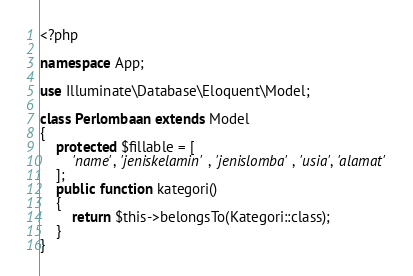Convert code to text. <code><loc_0><loc_0><loc_500><loc_500><_PHP_><?php

namespace App;

use Illuminate\Database\Eloquent\Model;

class Perlombaan extends Model
{
    protected $fillable = [
        'name', 'jeniskelamin', 'jenislomba', 'usia', 'alamat'
    ];
    public function kategori()
    {
        return $this->belongsTo(Kategori::class);
    }
}
</code> 